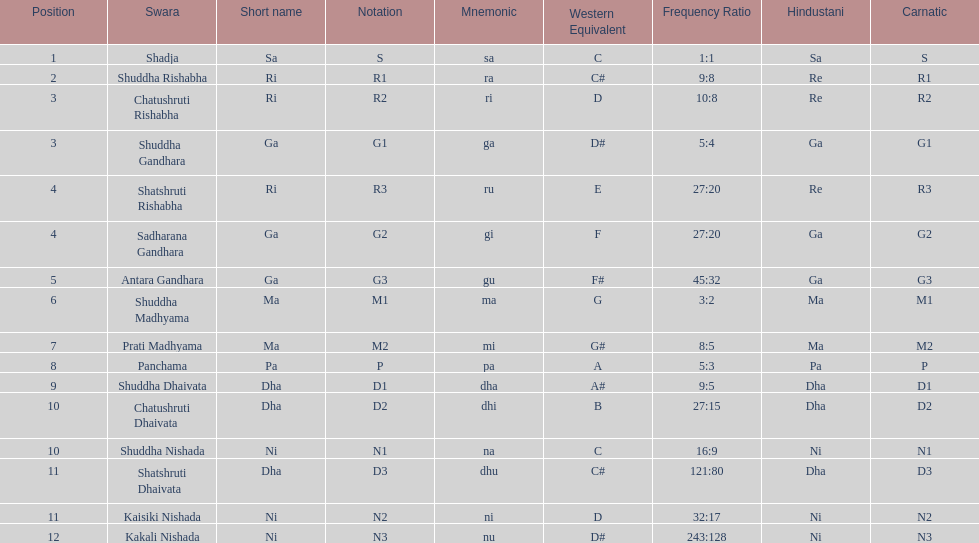What is the name of the swara that holds the first position? Shadja. 